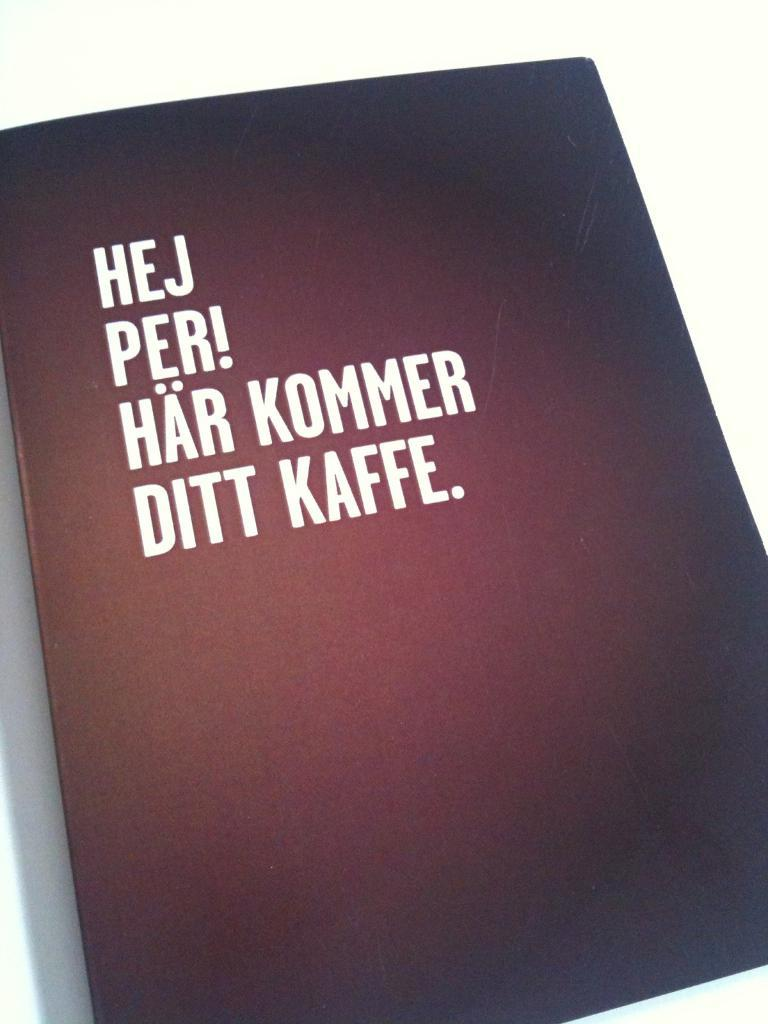<image>
Present a compact description of the photo's key features. a black book with the words Hej Per! Has Kommer Ditt Kaffe on it 